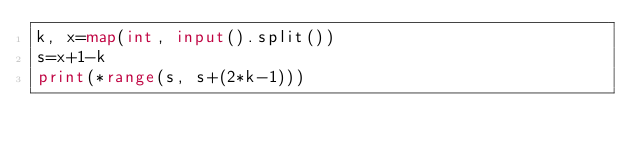Convert code to text. <code><loc_0><loc_0><loc_500><loc_500><_Python_>k, x=map(int, input().split())
s=x+1-k
print(*range(s, s+(2*k-1)))</code> 